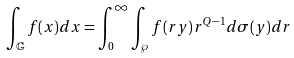<formula> <loc_0><loc_0><loc_500><loc_500>\int _ { \mathbb { G } } f ( x ) d x = \int _ { 0 } ^ { \infty } \int _ { \wp } f ( r y ) r ^ { Q - 1 } d \sigma ( y ) d r</formula> 